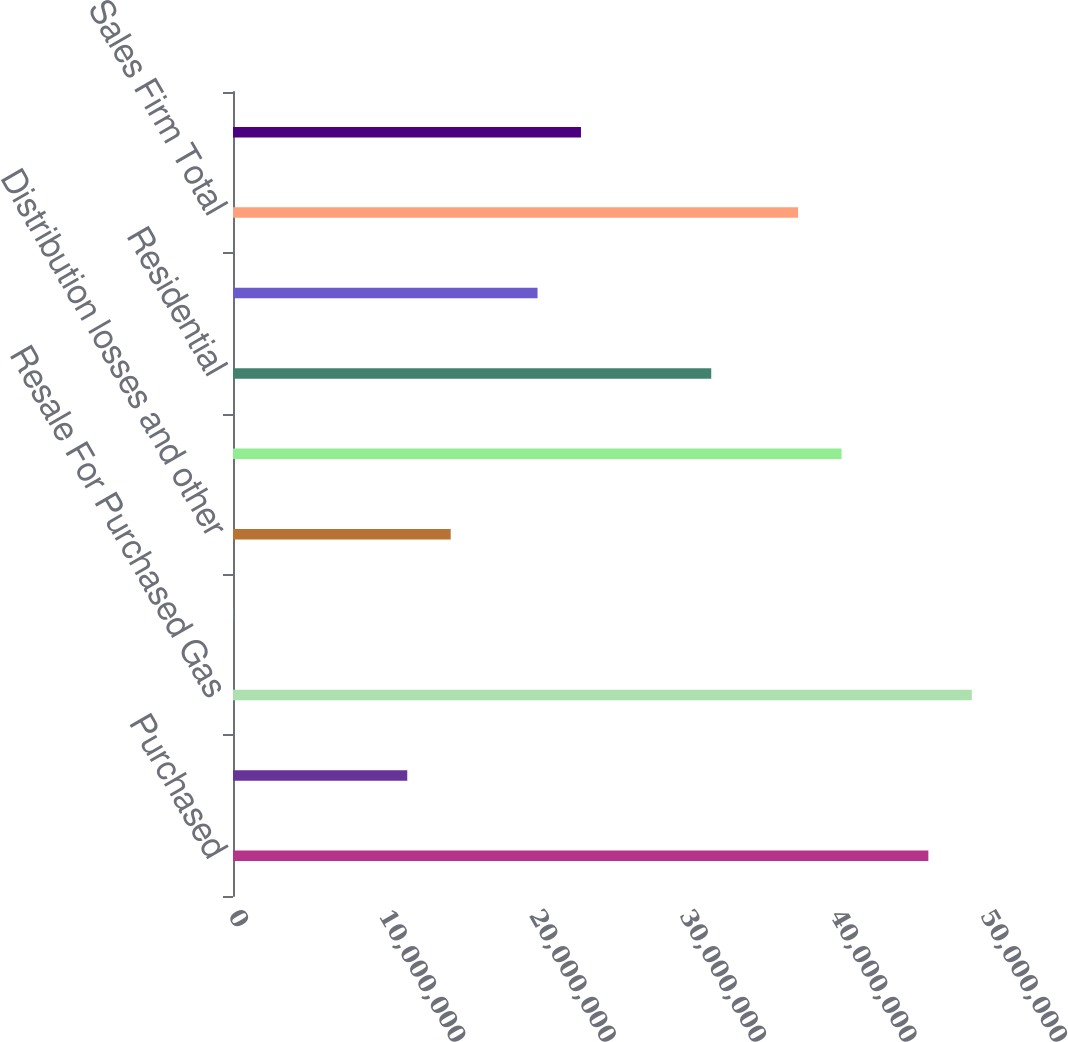Convert chart to OTSL. <chart><loc_0><loc_0><loc_500><loc_500><bar_chart><fcel>Purchased<fcel>Storage - net change<fcel>Resale For Purchased Gas<fcel>Less Gas used by the company<fcel>Distribution losses and other<fcel>Total Gas Purchased For O&R<fcel>Residential<fcel>General<fcel>Sales Firm Total<fcel>Interruptible Sales<nl><fcel>4.62343e+07<fcel>1.15868e+07<fcel>4.91216e+07<fcel>37630<fcel>1.44741e+07<fcel>4.04597e+07<fcel>3.17978e+07<fcel>2.02487e+07<fcel>3.75724e+07<fcel>2.31359e+07<nl></chart> 